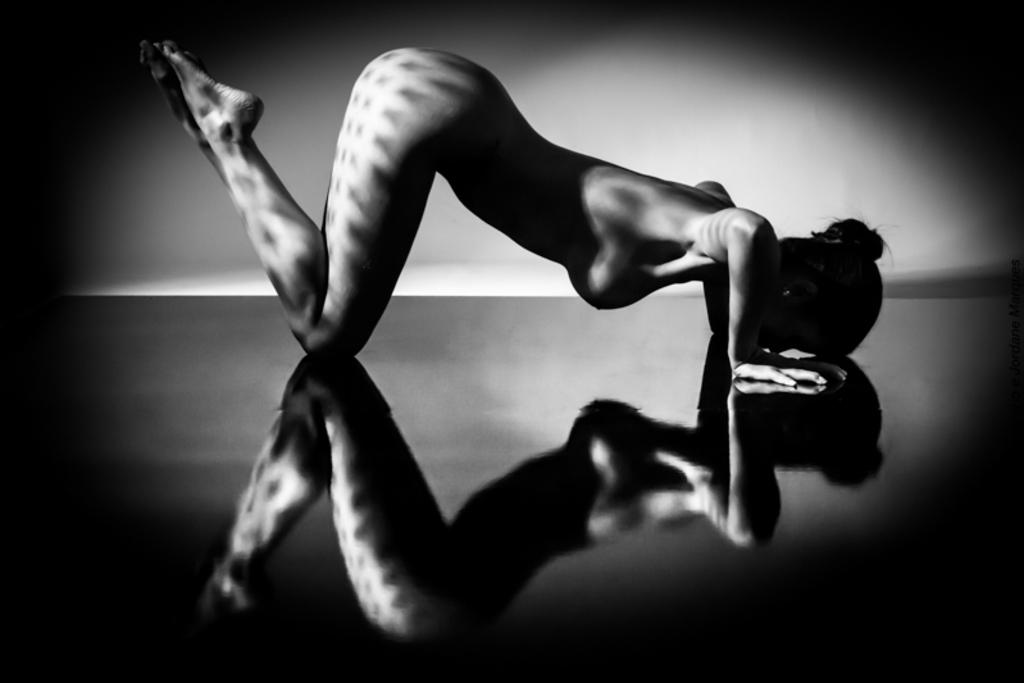Who is present in the image? There is a woman in the image. What is the woman doing in the image? The woman is on the floor. Is there any additional information about the woman's appearance in the image? Yes, there is a reflection of the woman in the image. What is the color scheme of the image? The image is black and white in color. What type of gun is the woman holding in the image? There is no gun present in the image; it features a woman on the floor with a reflection. 